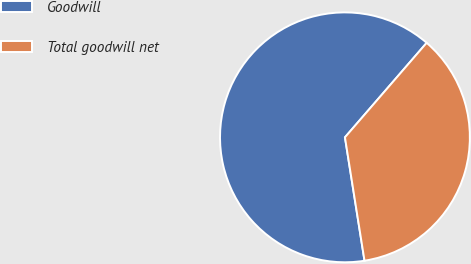Convert chart to OTSL. <chart><loc_0><loc_0><loc_500><loc_500><pie_chart><fcel>Goodwill<fcel>Total goodwill net<nl><fcel>63.85%<fcel>36.15%<nl></chart> 